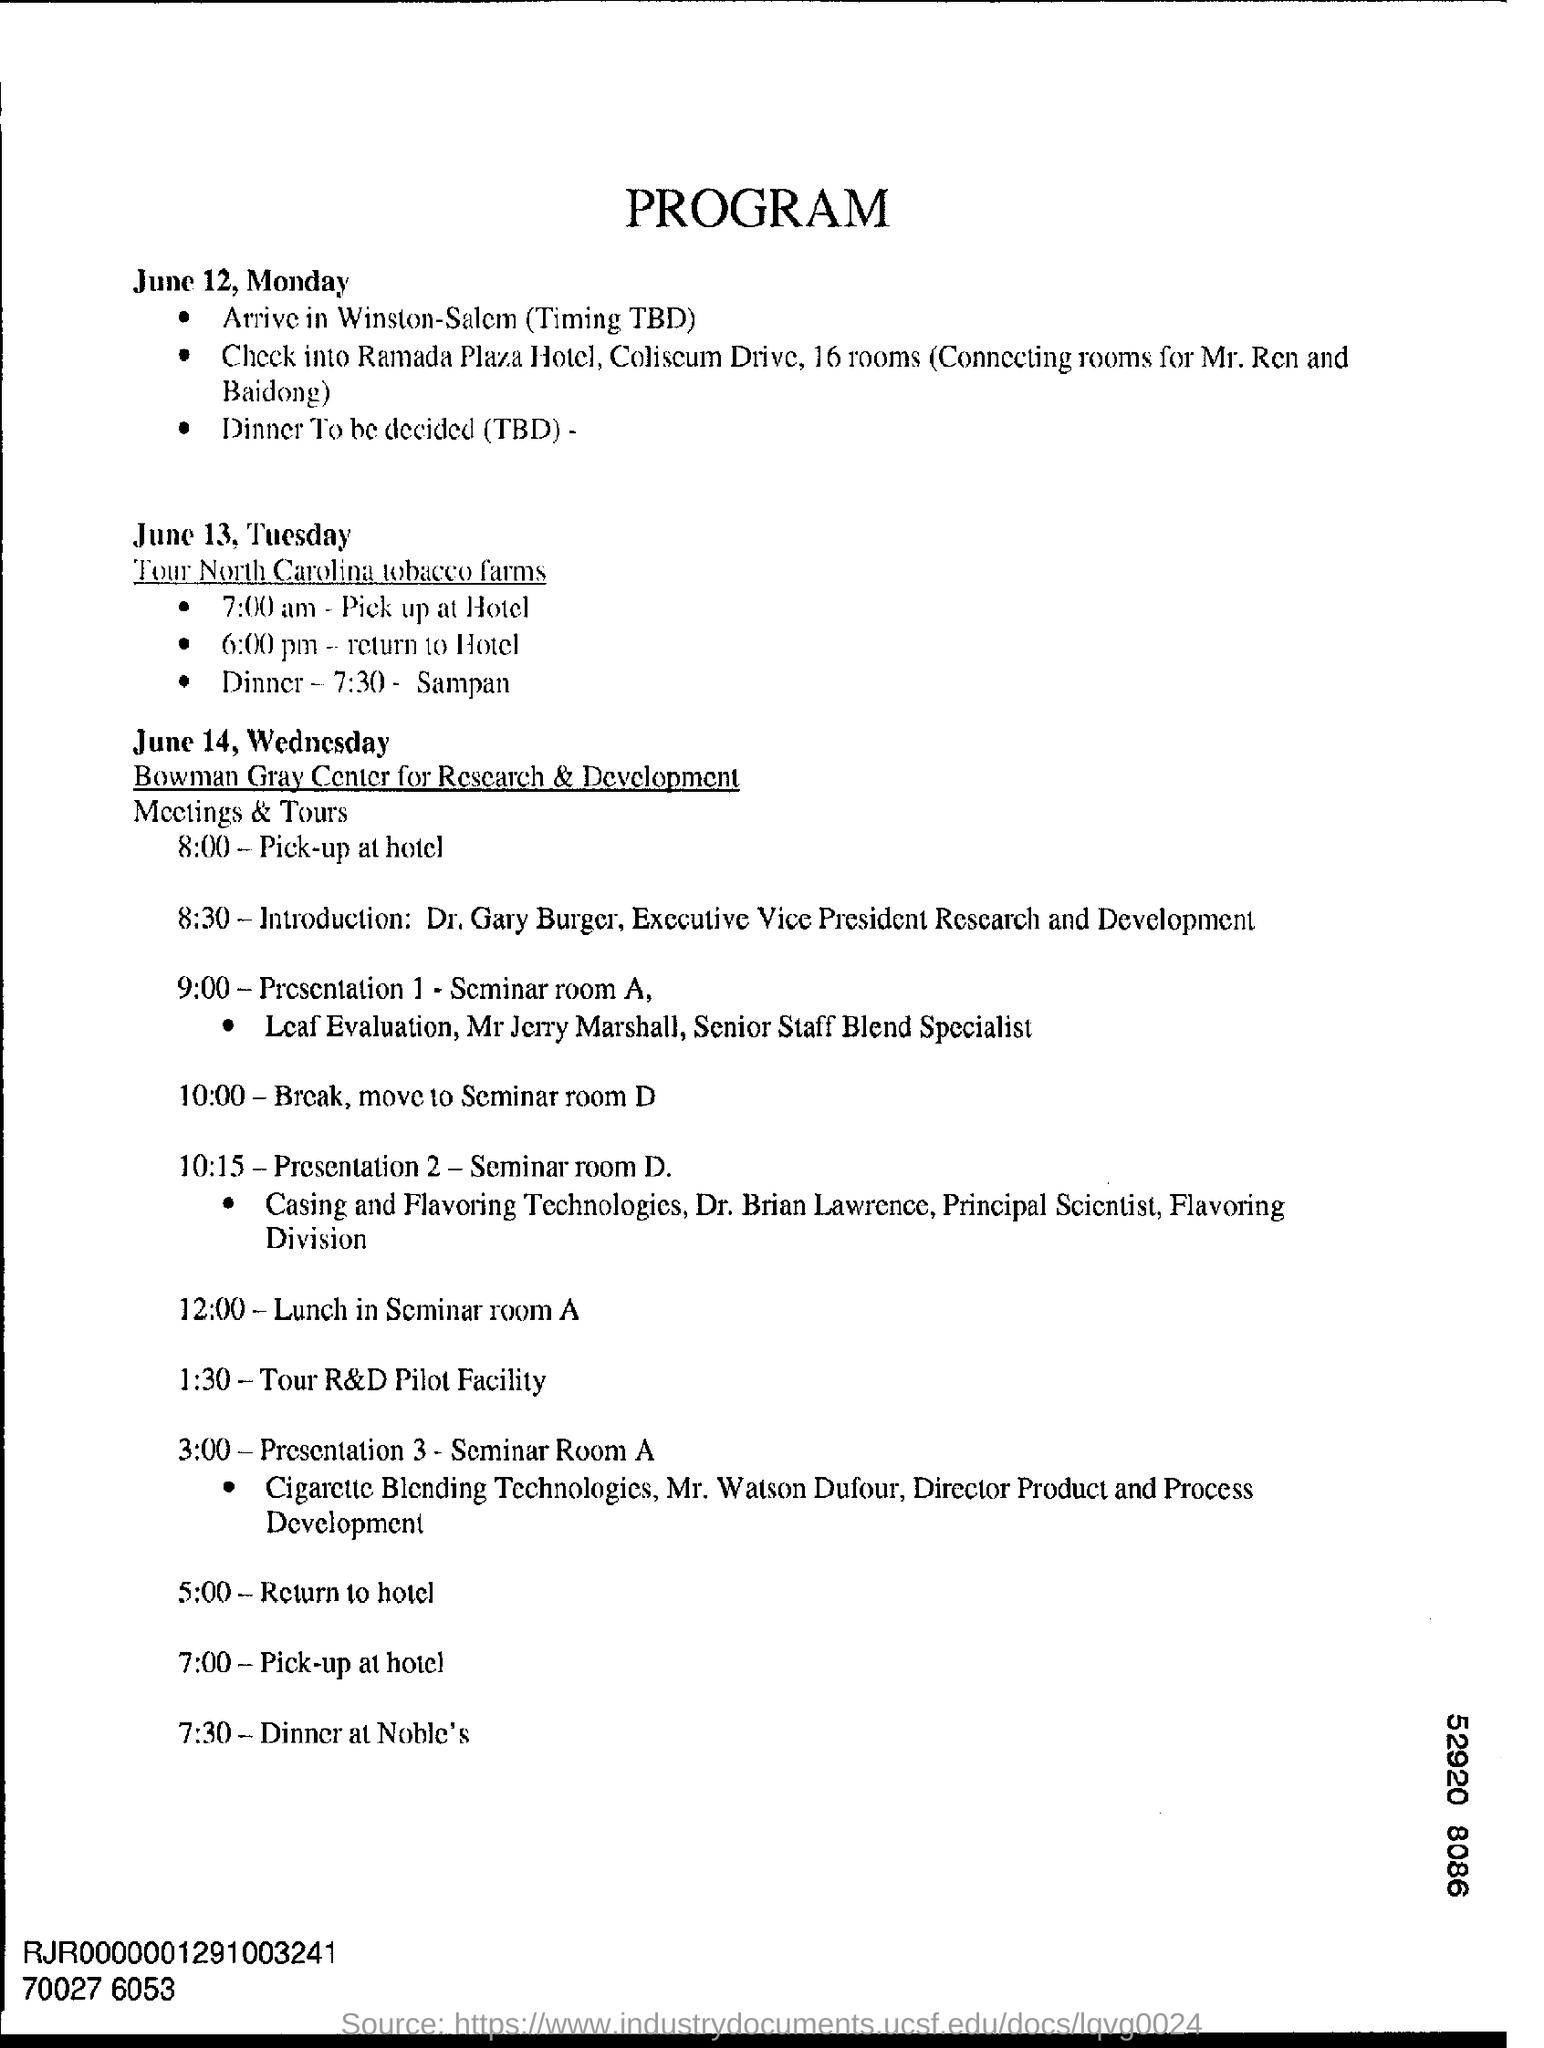What is the first date mentioned?
Make the answer very short. June 12, Monday. Where are they going to arrive?
Provide a succinct answer. Winston. Where are they going for Dinner at 7:30 on June 14, Wednesday?
Offer a terse response. At Noble's. 